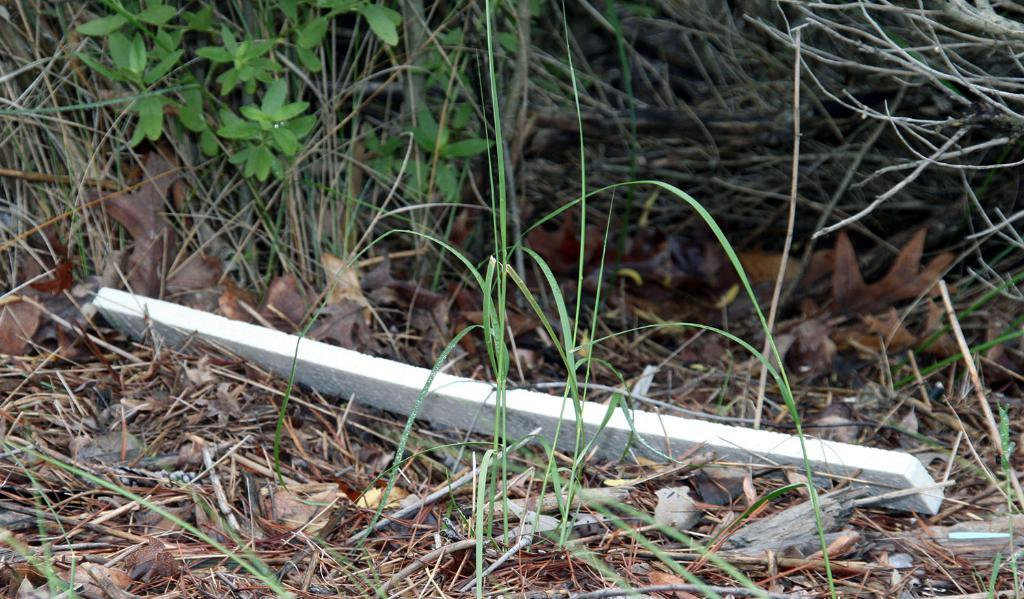What type of surface is visible in the image? There is a grassy path in the image. How does the grass on the path appear? The grass on the path appears to be dried. What can be seen growing alongside the path? There are grass plants and small plant saplings on the path. What object is present on the path? There is a slate pencil on the path. What color is the slate pencil? The slate pencil is white in color. What type of party is being held on the grassy path in the image? There is no party visible in the image; it only shows a grassy path with dried grass, plants, and a white slate pencil. 